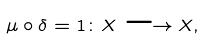Convert formula to latex. <formula><loc_0><loc_0><loc_500><loc_500>\mu \circ \delta = 1 \colon X \longrightarrow X ,</formula> 